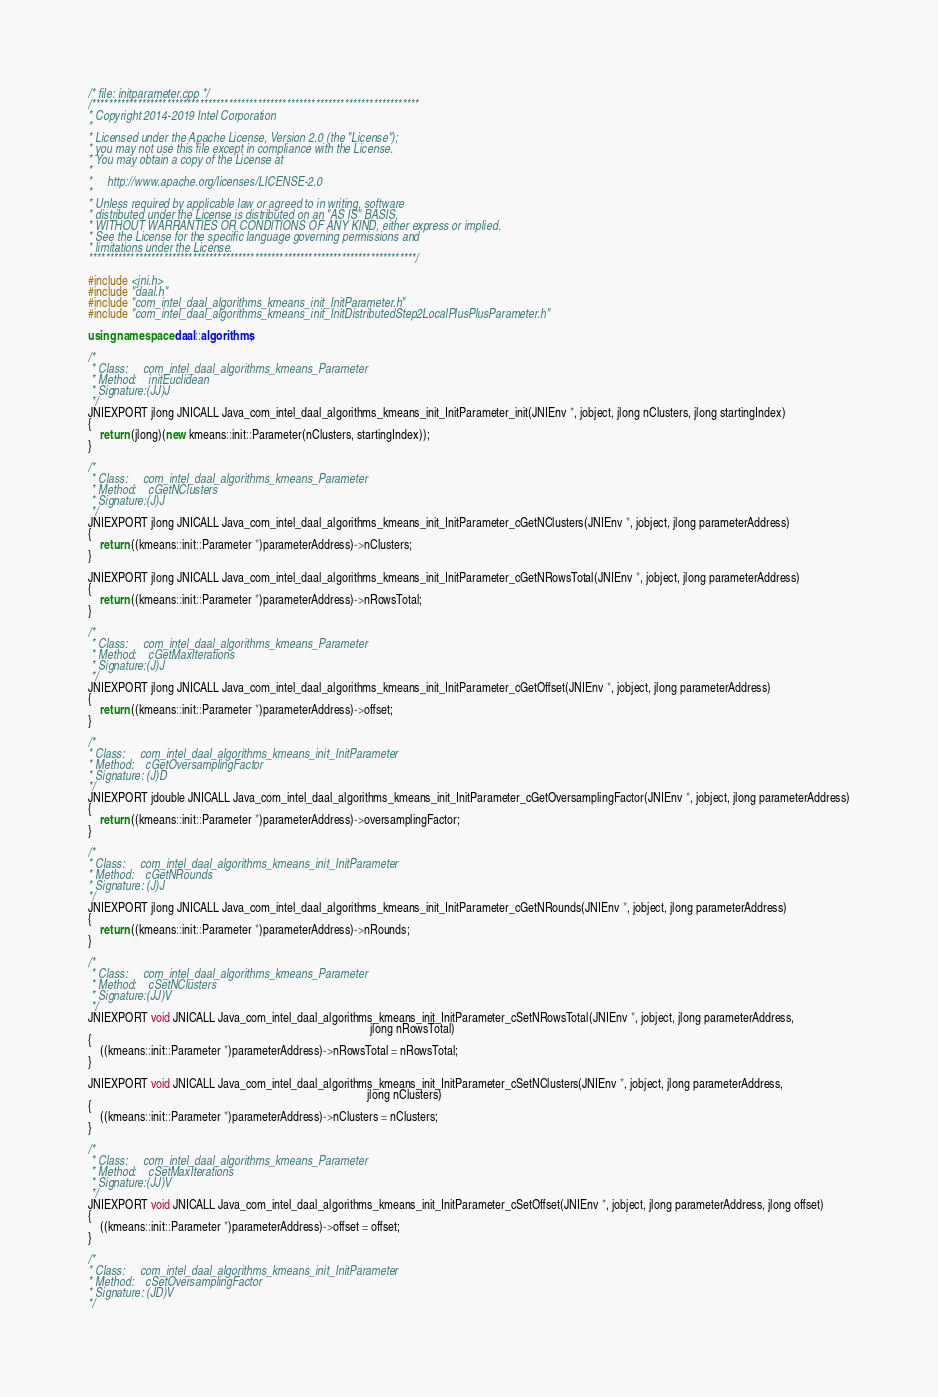<code> <loc_0><loc_0><loc_500><loc_500><_C++_>/* file: initparameter.cpp */
/*******************************************************************************
* Copyright 2014-2019 Intel Corporation
*
* Licensed under the Apache License, Version 2.0 (the "License");
* you may not use this file except in compliance with the License.
* You may obtain a copy of the License at
*
*     http://www.apache.org/licenses/LICENSE-2.0
*
* Unless required by applicable law or agreed to in writing, software
* distributed under the License is distributed on an "AS IS" BASIS,
* WITHOUT WARRANTIES OR CONDITIONS OF ANY KIND, either express or implied.
* See the License for the specific language governing permissions and
* limitations under the License.
*******************************************************************************/

#include <jni.h>
#include "daal.h"
#include "com_intel_daal_algorithms_kmeans_init_InitParameter.h"
#include "com_intel_daal_algorithms_kmeans_init_InitDistributedStep2LocalPlusPlusParameter.h"

using namespace daal::algorithms;

/*
 * Class:     com_intel_daal_algorithms_kmeans_Parameter
 * Method:    initEuclidean
 * Signature:(JJ)J
 */
JNIEXPORT jlong JNICALL Java_com_intel_daal_algorithms_kmeans_init_InitParameter_init(JNIEnv *, jobject, jlong nClusters, jlong startingIndex)
{
    return (jlong)(new kmeans::init::Parameter(nClusters, startingIndex));
}

/*
 * Class:     com_intel_daal_algorithms_kmeans_Parameter
 * Method:    cGetNClusters
 * Signature:(J)J
 */
JNIEXPORT jlong JNICALL Java_com_intel_daal_algorithms_kmeans_init_InitParameter_cGetNClusters(JNIEnv *, jobject, jlong parameterAddress)
{
    return ((kmeans::init::Parameter *)parameterAddress)->nClusters;
}

JNIEXPORT jlong JNICALL Java_com_intel_daal_algorithms_kmeans_init_InitParameter_cGetNRowsTotal(JNIEnv *, jobject, jlong parameterAddress)
{
    return ((kmeans::init::Parameter *)parameterAddress)->nRowsTotal;
}

/*
 * Class:     com_intel_daal_algorithms_kmeans_Parameter
 * Method:    cGetMaxIterations
 * Signature:(J)J
 */
JNIEXPORT jlong JNICALL Java_com_intel_daal_algorithms_kmeans_init_InitParameter_cGetOffset(JNIEnv *, jobject, jlong parameterAddress)
{
    return ((kmeans::init::Parameter *)parameterAddress)->offset;
}

/*
* Class:     com_intel_daal_algorithms_kmeans_init_InitParameter
* Method:    cGetOversamplingFactor
* Signature: (J)D
*/
JNIEXPORT jdouble JNICALL Java_com_intel_daal_algorithms_kmeans_init_InitParameter_cGetOversamplingFactor(JNIEnv *, jobject, jlong parameterAddress)
{
    return ((kmeans::init::Parameter *)parameterAddress)->oversamplingFactor;
}

/*
* Class:     com_intel_daal_algorithms_kmeans_init_InitParameter
* Method:    cGetNRounds
* Signature: (J)J
*/
JNIEXPORT jlong JNICALL Java_com_intel_daal_algorithms_kmeans_init_InitParameter_cGetNRounds(JNIEnv *, jobject, jlong parameterAddress)
{
    return ((kmeans::init::Parameter *)parameterAddress)->nRounds;
}

/*
 * Class:     com_intel_daal_algorithms_kmeans_Parameter
 * Method:    cSetNClusters
 * Signature:(JJ)V
 */
JNIEXPORT void JNICALL Java_com_intel_daal_algorithms_kmeans_init_InitParameter_cSetNRowsTotal(JNIEnv *, jobject, jlong parameterAddress,
                                                                                               jlong nRowsTotal)
{
    ((kmeans::init::Parameter *)parameterAddress)->nRowsTotal = nRowsTotal;
}

JNIEXPORT void JNICALL Java_com_intel_daal_algorithms_kmeans_init_InitParameter_cSetNClusters(JNIEnv *, jobject, jlong parameterAddress,
                                                                                              jlong nClusters)
{
    ((kmeans::init::Parameter *)parameterAddress)->nClusters = nClusters;
}

/*
 * Class:     com_intel_daal_algorithms_kmeans_Parameter
 * Method:    cSetMaxIterations
 * Signature:(JJ)V
 */
JNIEXPORT void JNICALL Java_com_intel_daal_algorithms_kmeans_init_InitParameter_cSetOffset(JNIEnv *, jobject, jlong parameterAddress, jlong offset)
{
    ((kmeans::init::Parameter *)parameterAddress)->offset = offset;
}

/*
* Class:     com_intel_daal_algorithms_kmeans_init_InitParameter
* Method:    cSetOversamplingFactor
* Signature: (JD)V
*/</code> 